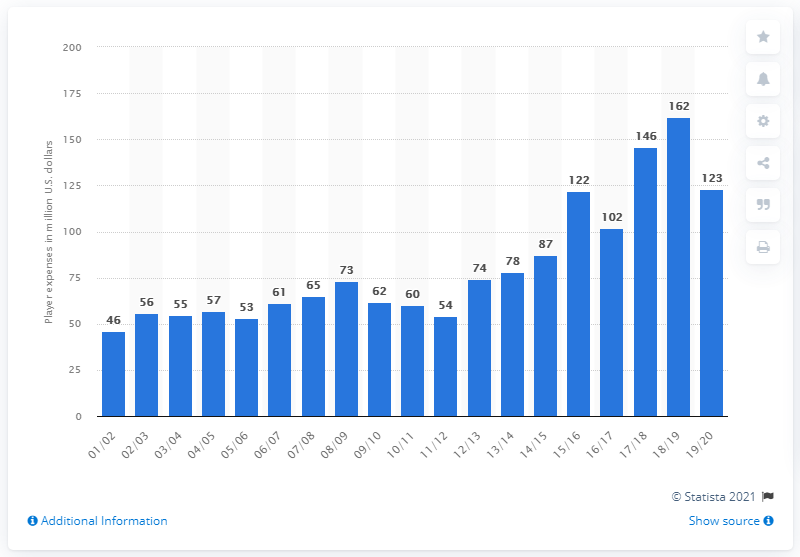Draw attention to some important aspects in this diagram. The player salaries of the Oklahoma City Thunder during the 2019/20 season were $123 million in dollars. 